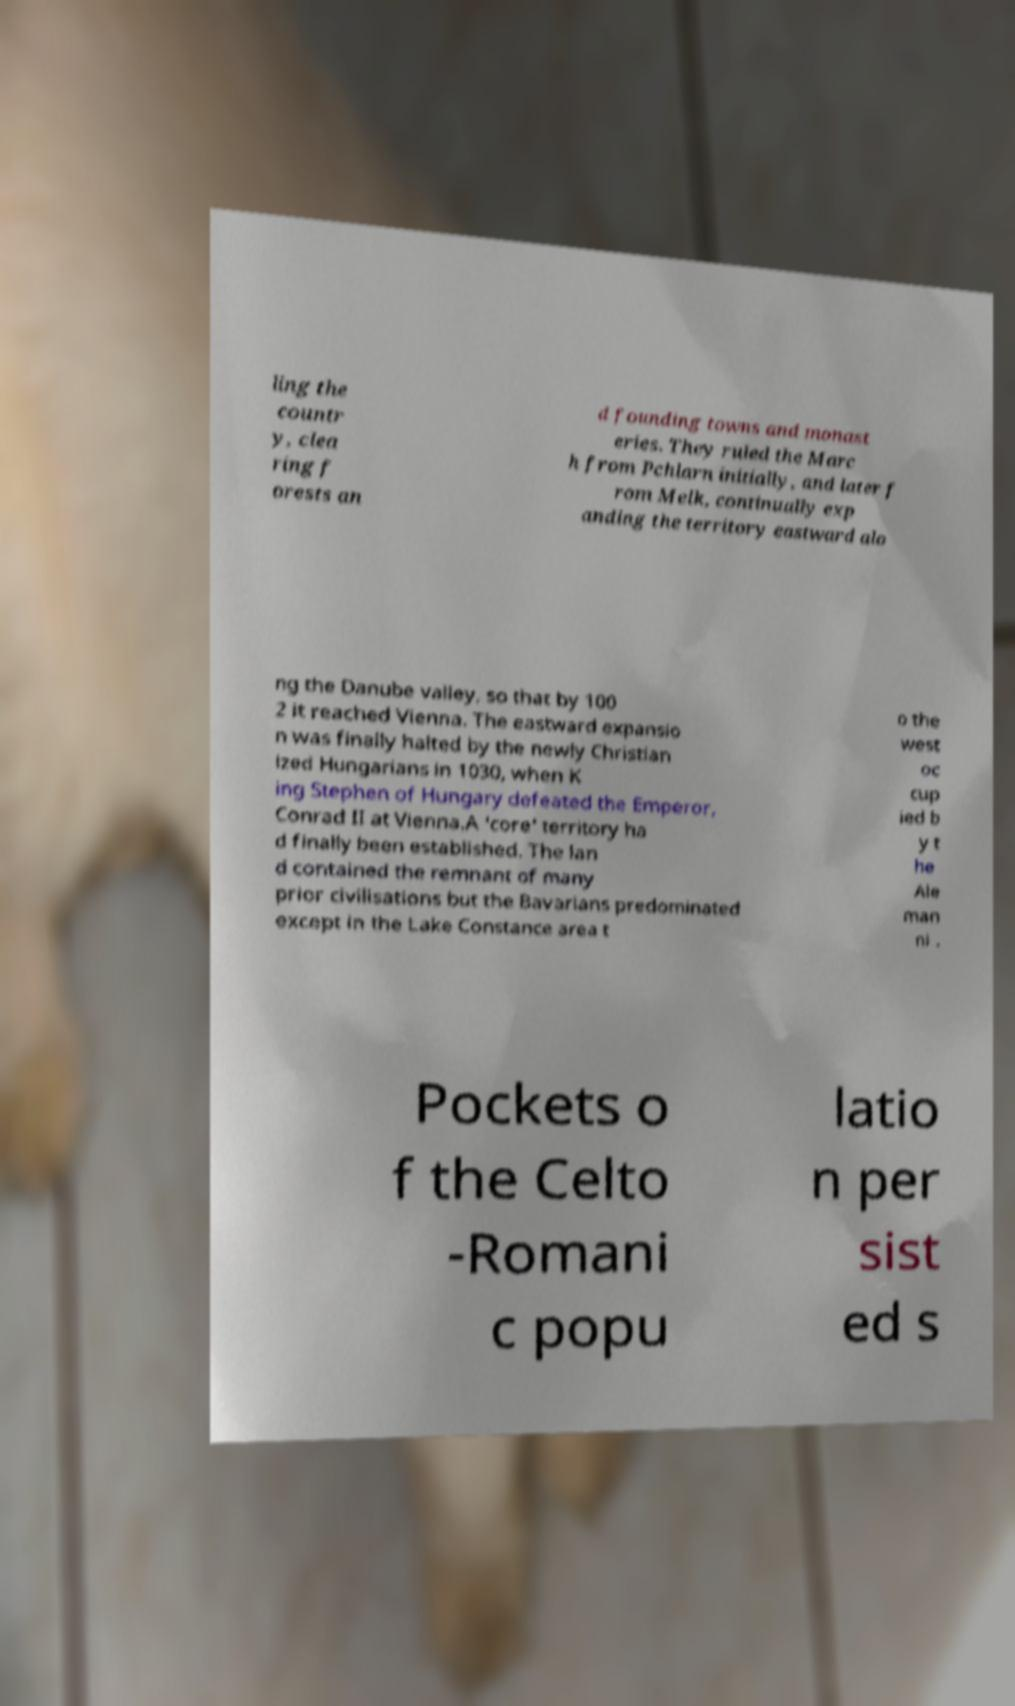Please read and relay the text visible in this image. What does it say? ling the countr y, clea ring f orests an d founding towns and monast eries. They ruled the Marc h from Pchlarn initially, and later f rom Melk, continually exp anding the territory eastward alo ng the Danube valley, so that by 100 2 it reached Vienna. The eastward expansio n was finally halted by the newly Christian ized Hungarians in 1030, when K ing Stephen of Hungary defeated the Emperor, Conrad II at Vienna.A 'core' territory ha d finally been established. The lan d contained the remnant of many prior civilisations but the Bavarians predominated except in the Lake Constance area t o the west oc cup ied b y t he Ale man ni . Pockets o f the Celto -Romani c popu latio n per sist ed s 